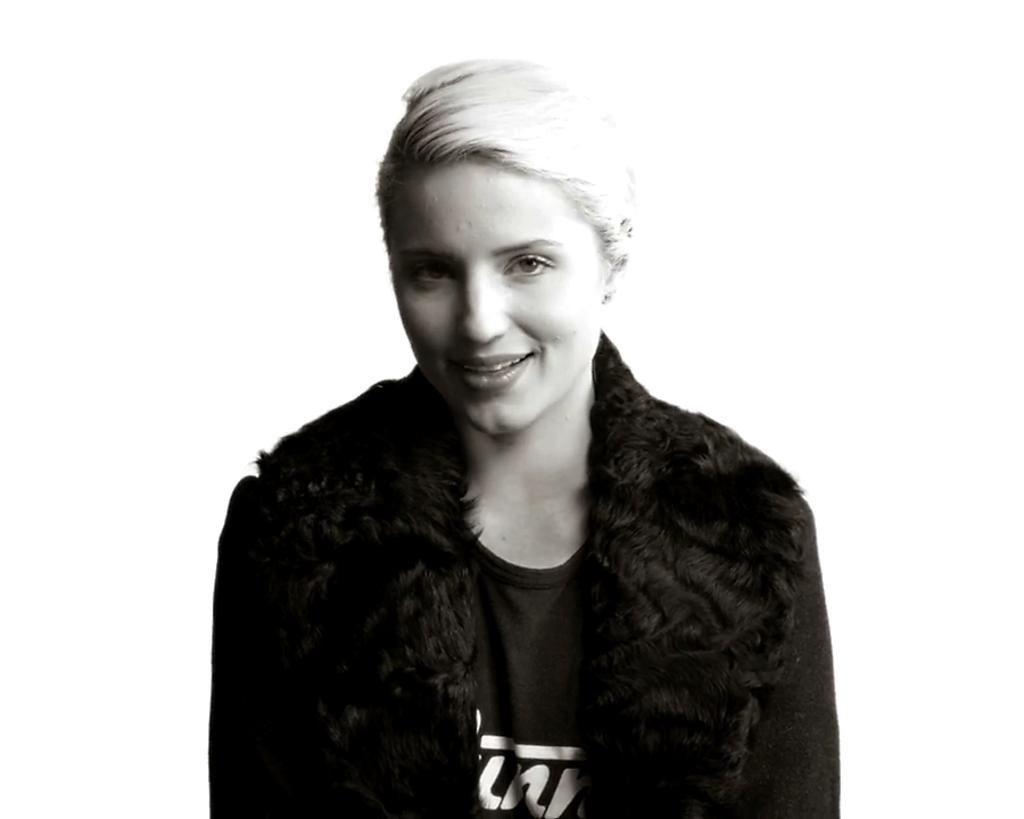What is the color scheme of the image? The image is black and white. Who is present in the image? There is a woman in the image. What type of clothing is the woman wearing? The woman is wearing a t-shirt and a coat. What is the woman's facial expression in the image? The woman is smiling. What type of quill is the woman holding in the image? There is no quill present in the image. What kind of plant can be seen growing near the woman in the image? There is no plant visible in the image. 